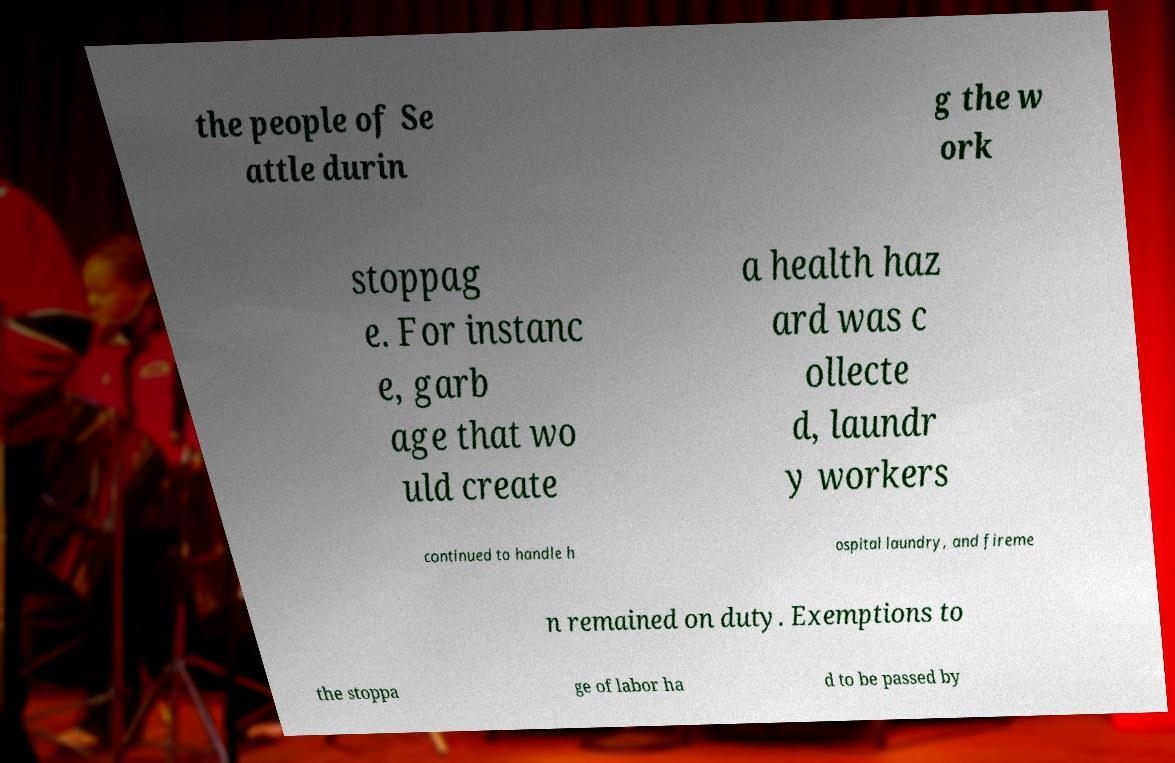Can you read and provide the text displayed in the image?This photo seems to have some interesting text. Can you extract and type it out for me? the people of Se attle durin g the w ork stoppag e. For instanc e, garb age that wo uld create a health haz ard was c ollecte d, laundr y workers continued to handle h ospital laundry, and fireme n remained on duty. Exemptions to the stoppa ge of labor ha d to be passed by 